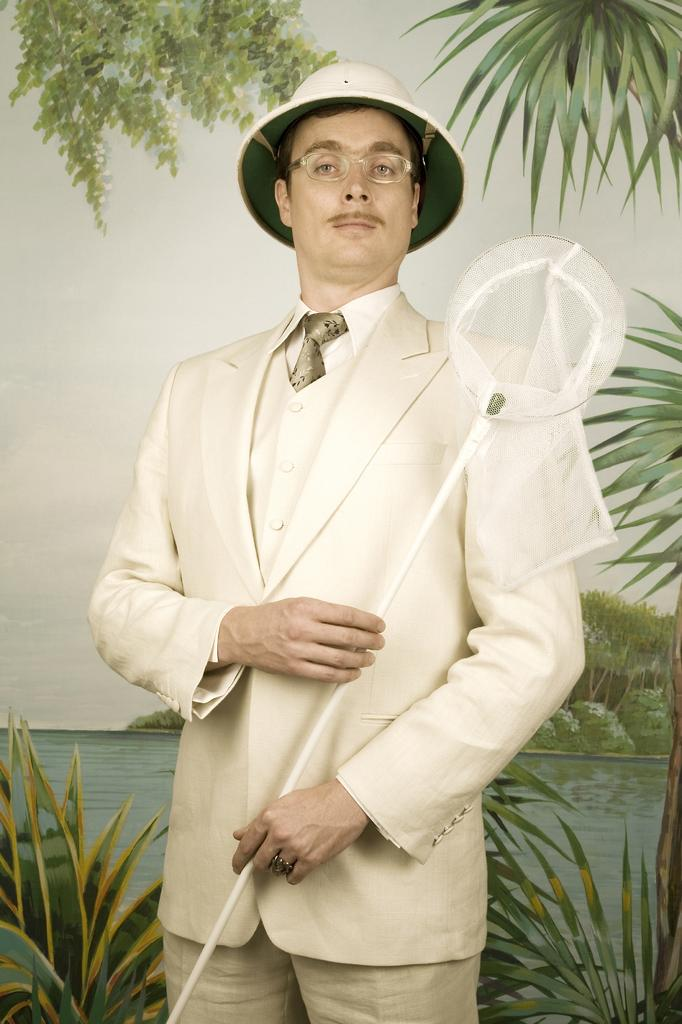What can be seen in the background of the image? In the background of the image, there is sky, water, and trees visible. What type of vegetation is present in the image? There are plants in the image. Who is in the image? There is a man in the image. What is the man wearing on his head? The man is wearing a hat. What is the man wearing on his face? The man is wearing spectacles. What is the man holding in his hands? The man is holding a white object in his hands. How many quinces are being used as a drink in the image? There are no quinces or drinks present in the image. What type of men are visible in the image? There is only one man visible in the image. 